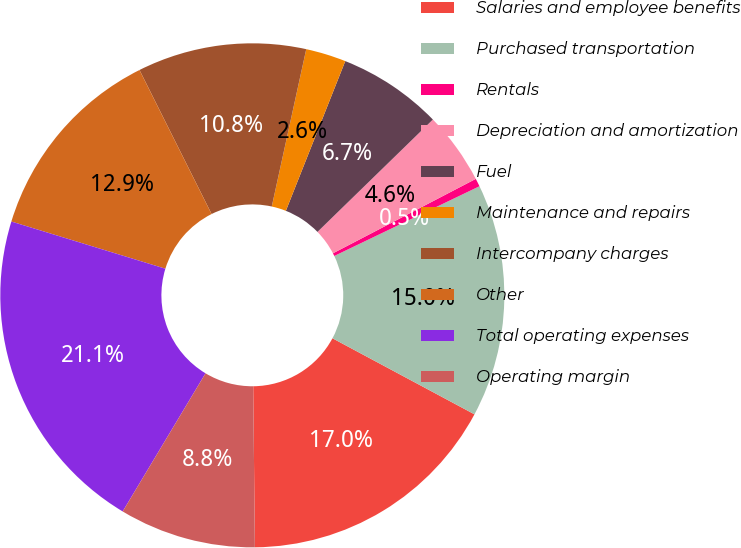<chart> <loc_0><loc_0><loc_500><loc_500><pie_chart><fcel>Salaries and employee benefits<fcel>Purchased transportation<fcel>Rentals<fcel>Depreciation and amortization<fcel>Fuel<fcel>Maintenance and repairs<fcel>Intercompany charges<fcel>Other<fcel>Total operating expenses<fcel>Operating margin<nl><fcel>17.01%<fcel>14.95%<fcel>0.52%<fcel>4.64%<fcel>6.7%<fcel>2.58%<fcel>10.82%<fcel>12.88%<fcel>21.13%<fcel>8.76%<nl></chart> 